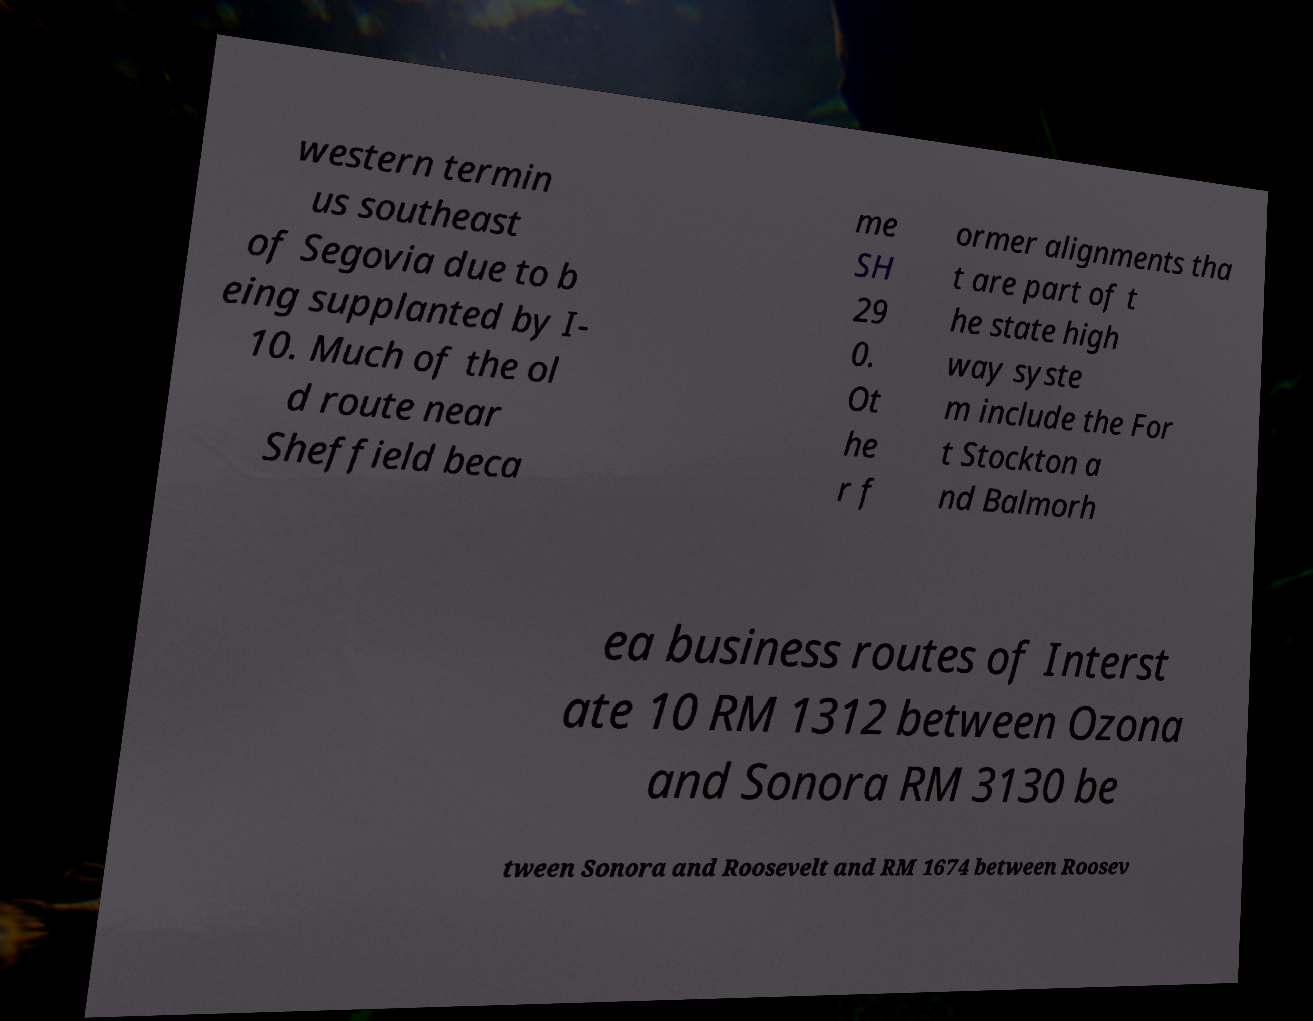Could you extract and type out the text from this image? western termin us southeast of Segovia due to b eing supplanted by I- 10. Much of the ol d route near Sheffield beca me SH 29 0. Ot he r f ormer alignments tha t are part of t he state high way syste m include the For t Stockton a nd Balmorh ea business routes of Interst ate 10 RM 1312 between Ozona and Sonora RM 3130 be tween Sonora and Roosevelt and RM 1674 between Roosev 